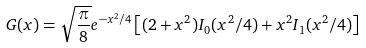<formula> <loc_0><loc_0><loc_500><loc_500>G ( x ) = \sqrt { \frac { \pi } { 8 } } e ^ { - x ^ { 2 } / 4 } \left [ ( 2 + x ^ { 2 } ) I _ { 0 } ( x ^ { 2 } / 4 ) + x ^ { 2 } I _ { 1 } ( x ^ { 2 } / 4 ) \right ]</formula> 